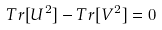Convert formula to latex. <formula><loc_0><loc_0><loc_500><loc_500>T r [ U ^ { 2 } ] - T r [ V ^ { 2 } ] = 0</formula> 